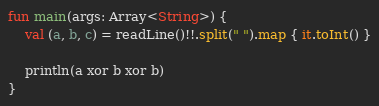Convert code to text. <code><loc_0><loc_0><loc_500><loc_500><_Kotlin_>fun main(args: Array<String>) {
    val (a, b, c) = readLine()!!.split(" ").map { it.toInt() }

    println(a xor b xor b)
}</code> 